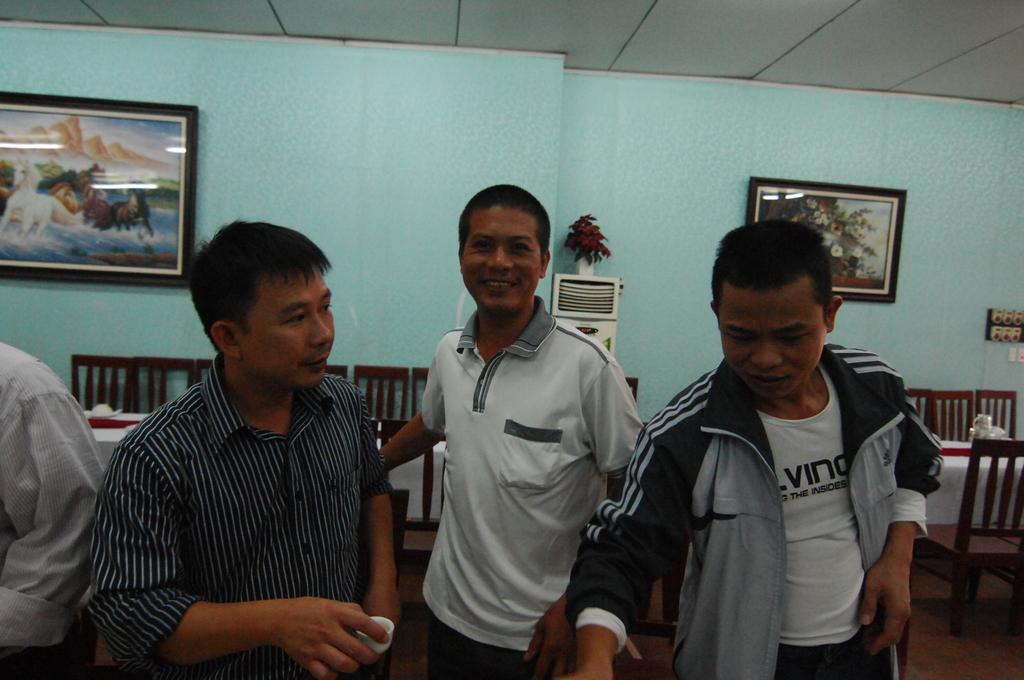In one or two sentences, can you explain what this image depicts? In the center of the image we can see four people are standing. Among them, we can see one person is holding an object. In the background there is a wall, frames, chairs and a few other objects. 